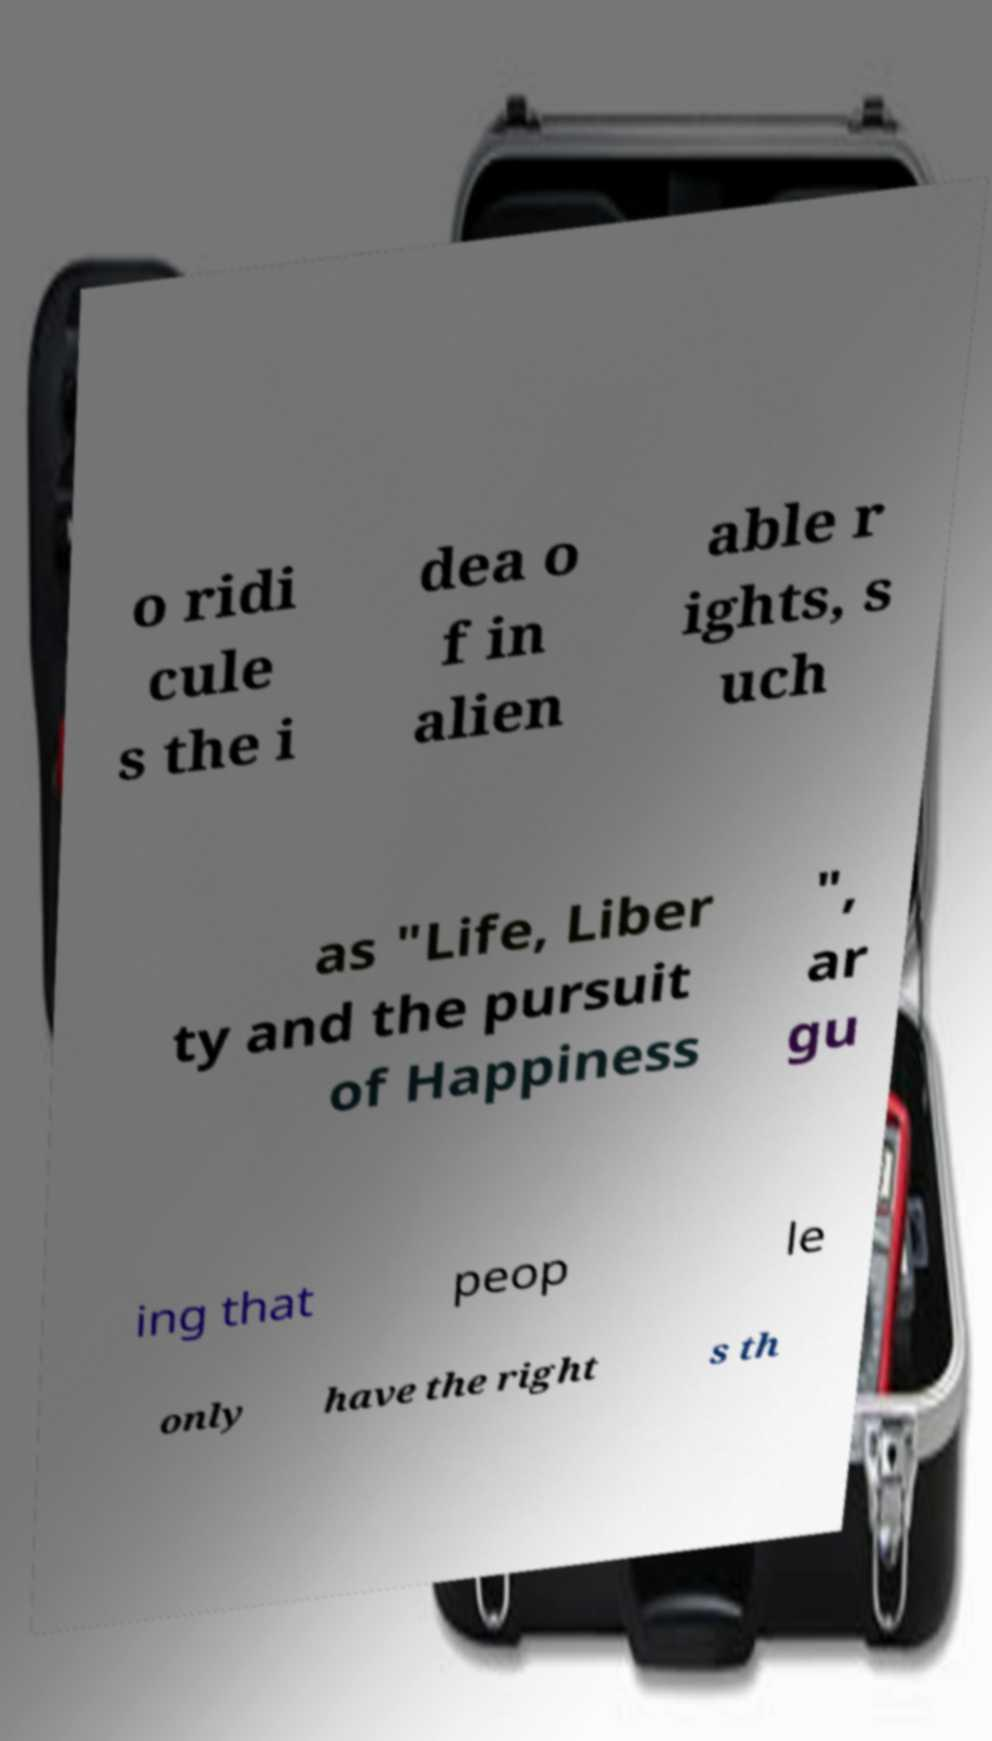Could you extract and type out the text from this image? o ridi cule s the i dea o f in alien able r ights, s uch as "Life, Liber ty and the pursuit of Happiness ", ar gu ing that peop le only have the right s th 